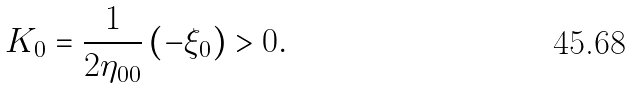Convert formula to latex. <formula><loc_0><loc_0><loc_500><loc_500>K _ { 0 } = \frac { 1 } { 2 \eta _ { 0 0 } } \left ( - \xi _ { 0 } \right ) > 0 .</formula> 